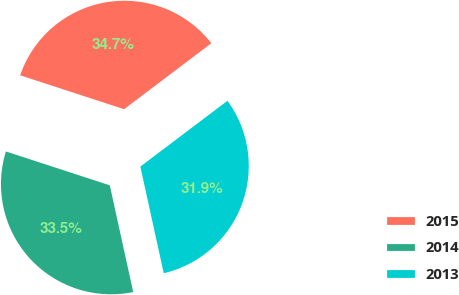Convert chart. <chart><loc_0><loc_0><loc_500><loc_500><pie_chart><fcel>2015<fcel>2014<fcel>2013<nl><fcel>34.69%<fcel>33.46%<fcel>31.86%<nl></chart> 